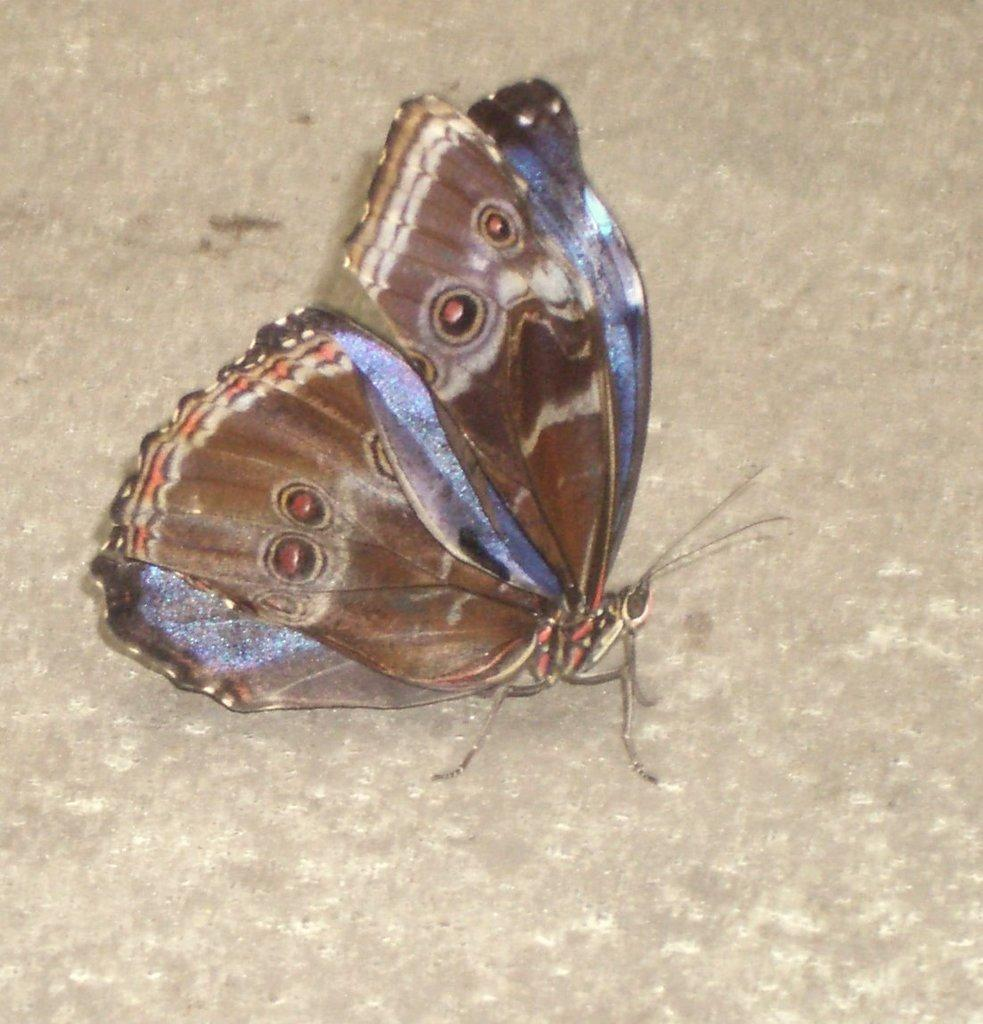What type of animal can be seen in the image? There is a butterfly in the image. Can you describe the appearance of the butterfly? The butterfly is in multiple colors. What arithmetic problem is the butterfly solving in the image? There is no arithmetic problem present in the image, as it features a butterfly. Can you tell me how deep the river is in the image? There is no river present in the image, only a butterfly. 